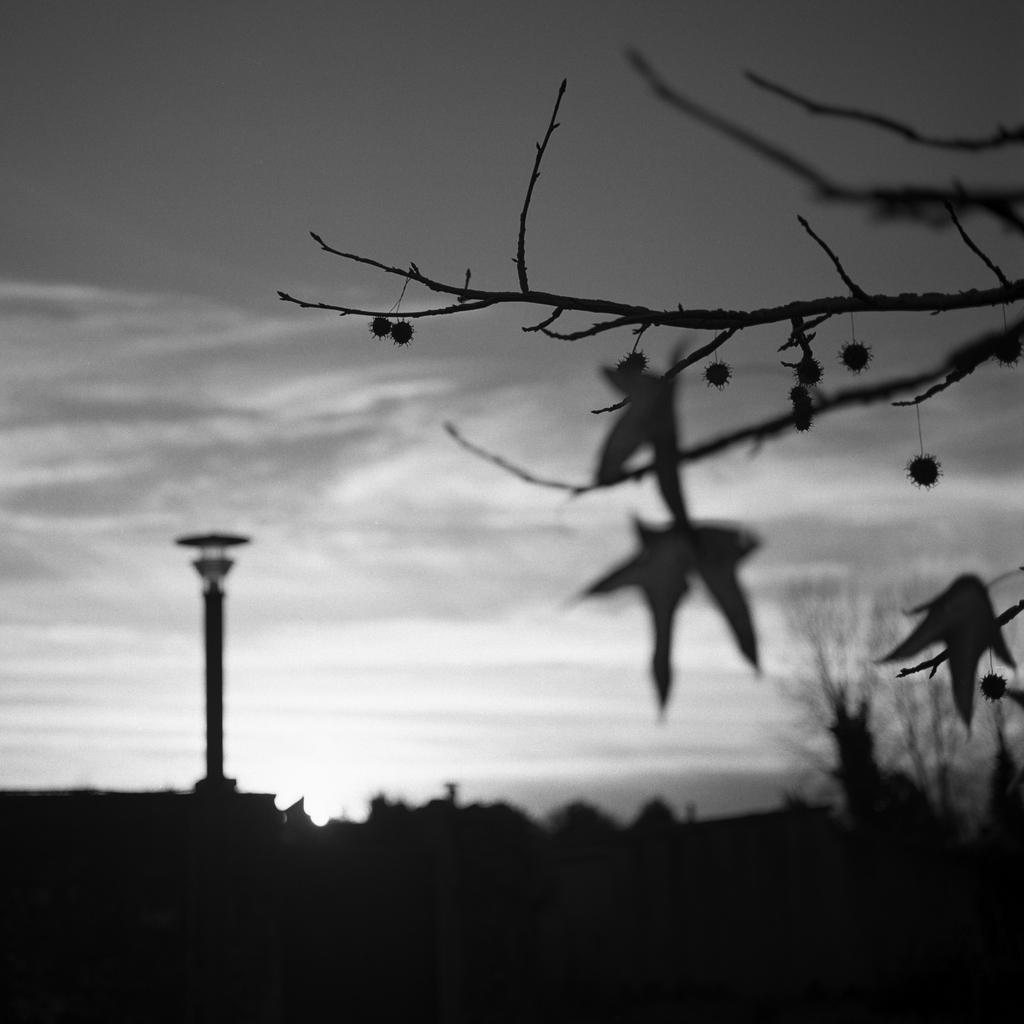What type of natural element is present in the image? There is a tree in the image. What is on the tree? There are objects on the tree. What structure can be seen in the image? There is a tower in the image. What else is present near the tower? There are other objects beside the tower. Can you see any metal balloons on the seashore in the image? There is no seashore or metal balloons present in the image. 